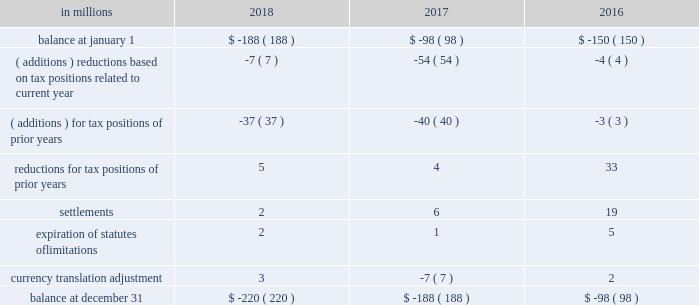( a ) the net change in the total valuation allowance for the years ended december 31 , 2018 and 2017 was an increase of $ 12 million and an increase of $ 26 million , respectively .
Deferred income tax assets and liabilities are recorded in the accompanying consolidated balance sheet under the captions deferred charges and other assets and deferred income taxes .
There was a decrease in deferred income tax assets principally relating to the utilization of u.s .
Federal alternative minimum tax credits as permitted under tax reform .
Deferred tax liabilities increased primarily due to the tax deferral of the book gain recognized on the transfer of the north american consumer packaging business to a subsidiary of graphic packaging holding company .
Of the $ 1.5 billion of deferred tax liabilities for forestlands , related installment sales , and investment in subsidiary , $ 884 million is attributable to an investment in subsidiary and relates to a 2006 international paper installment sale of forestlands and $ 538 million is attributable to a 2007 temple-inland installment sale of forestlands ( see note 14 ) .
A reconciliation of the beginning and ending amount of unrecognized tax benefits for the years ended december 31 , 2018 , 2017 and 2016 is as follows: .
If the company were to prevail on the unrecognized tax benefits recorded , substantially all of the balances at december 31 , 2018 , 2017 and 2016 would benefit the effective tax rate .
The company accrues interest on unrecognized tax benefits as a component of interest expense .
Penalties , if incurred , are recognized as a component of income tax expense .
The company had approximately $ 21 million and $ 17 million accrued for the payment of estimated interest and penalties associated with unrecognized tax benefits at december 31 , 2018 and 2017 , respectively .
The major jurisdictions where the company files income tax returns are the united states , brazil , france , poland and russia .
Generally , tax years 2006 through 2017 remain open and subject to examination by the relevant tax authorities .
The company frequently faces challenges regarding the amount of taxes due .
These challenges include positions taken by the company related to the timing , nature , and amount of deductions and the allocation of income among various tax jurisdictions .
Pending audit settlements and the expiration of statute of limitations could reduce the uncertain tax positions by $ 30 million during the next twelve months .
The brazilian federal revenue service has challenged the deductibility of goodwill amortization generated in a 2007 acquisition by international paper do brasil ltda. , a wholly-owned subsidiary of the company .
The company received assessments for the tax years 2007-2015 totaling approximately $ 150 million in tax , and $ 380 million in interest and penalties as of december 31 , 2018 ( adjusted for variation in currency exchange rates ) .
After a previous favorable ruling challenging the basis for these assessments , we received an unfavorable decision in october 2018 from the brazilian administrative council of tax appeals .
The company intends to further appeal the matter in the brazilian federal courts in 2019 ; however , this tax litigation matter may take many years to resolve .
The company believes that it has appropriately evaluated the transaction underlying these assessments , and has concluded based on brazilian tax law , that its tax position would be sustained .
The company intends to vigorously defend its position against the current assessments and any similar assessments that may be issued for tax years subsequent to 2015 .
International paper uses the flow-through method to account for investment tax credits earned on eligible open-loop biomass facilities and combined heat and power system expenditures .
Under this method , the investment tax credits are recognized as a reduction to income tax expense in the year they are earned rather than a reduction in the asset basis .
The company recorded a tax benefit of $ 6 million during 2018 and recorded a tax benefit of $ 68 million during 2017 related to investment tax credits earned in tax years 2013-2017. .
Unrecognized tax benefits change by what percent between 2017 and 2018? 
Computations: ((220 - 188) / 188)
Answer: 0.17021. 